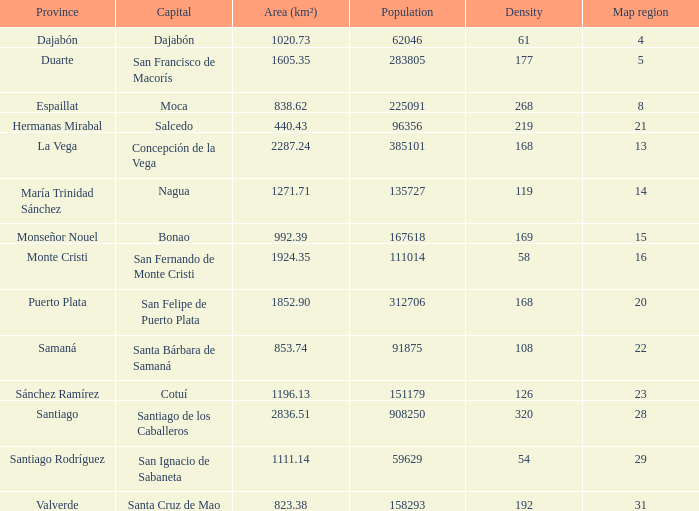What is the area (km²) of nagua? 1271.71. 